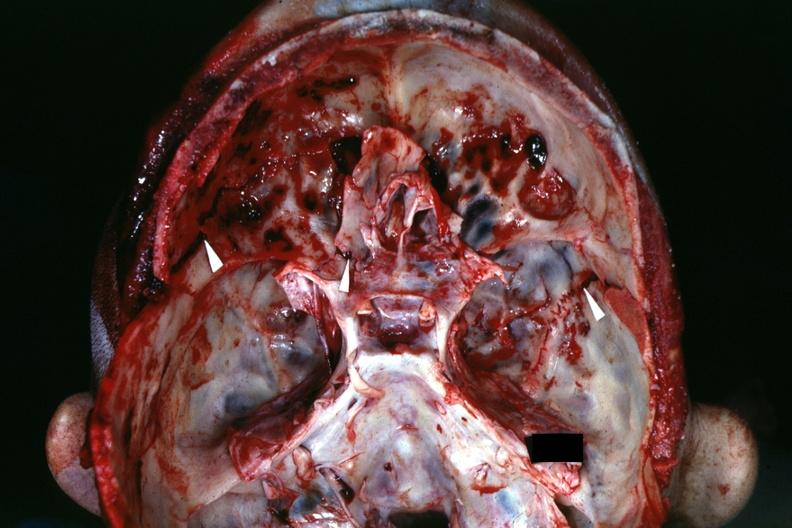what is view of base of skull with several shown?
Answer the question using a single word or phrase. Shown fractures 